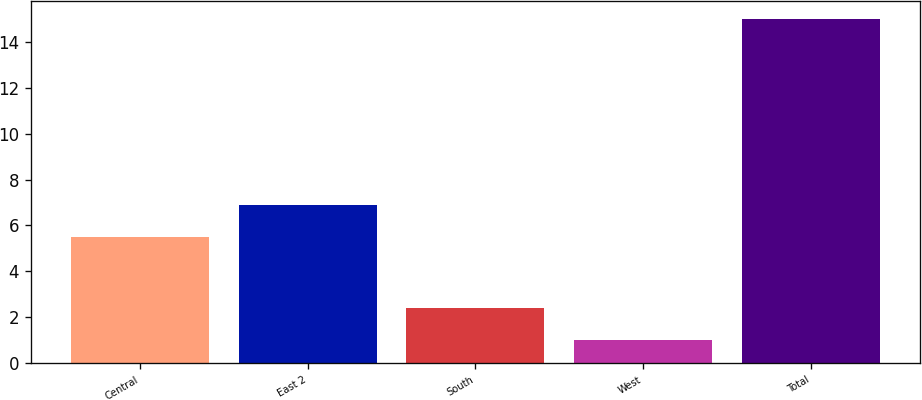Convert chart. <chart><loc_0><loc_0><loc_500><loc_500><bar_chart><fcel>Central<fcel>East 2<fcel>South<fcel>West<fcel>Total<nl><fcel>5.5<fcel>6.9<fcel>2.4<fcel>1<fcel>15<nl></chart> 